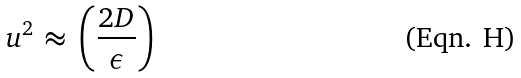<formula> <loc_0><loc_0><loc_500><loc_500>u ^ { 2 } \, \approx \, \left ( \frac { 2 D } { \epsilon } \right )</formula> 